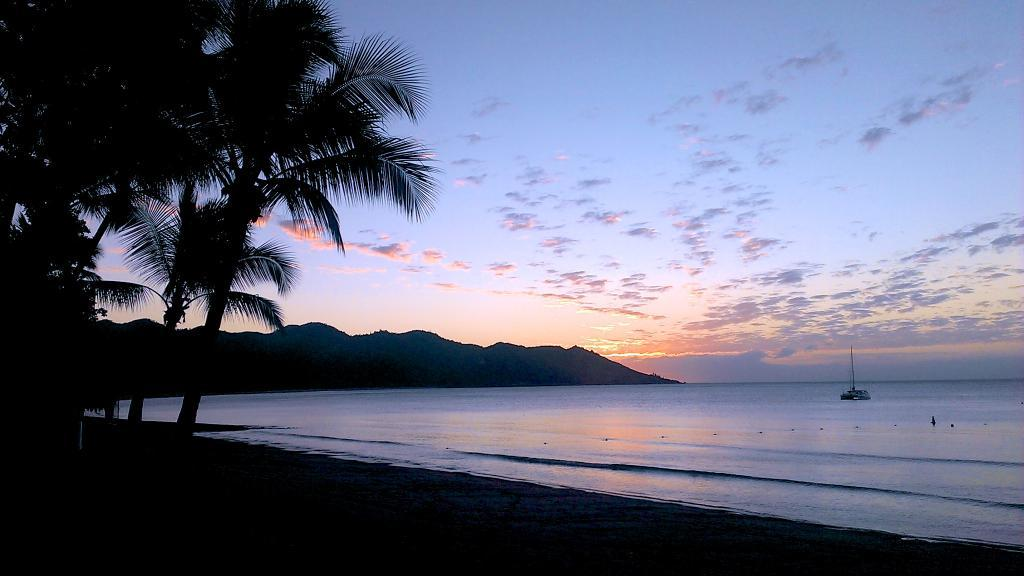What is the main subject of the image? The main subject of the image is a ship. Where is the ship located in the image? The ship is on the water and at the bottom side of the image. What type of environment can be seen in the image? There is greenery and the sky visible in the image. How many bricks are used to build the scene in the image? There are no bricks present in the image, as it features a ship on the water with greenery and the sky visible. 